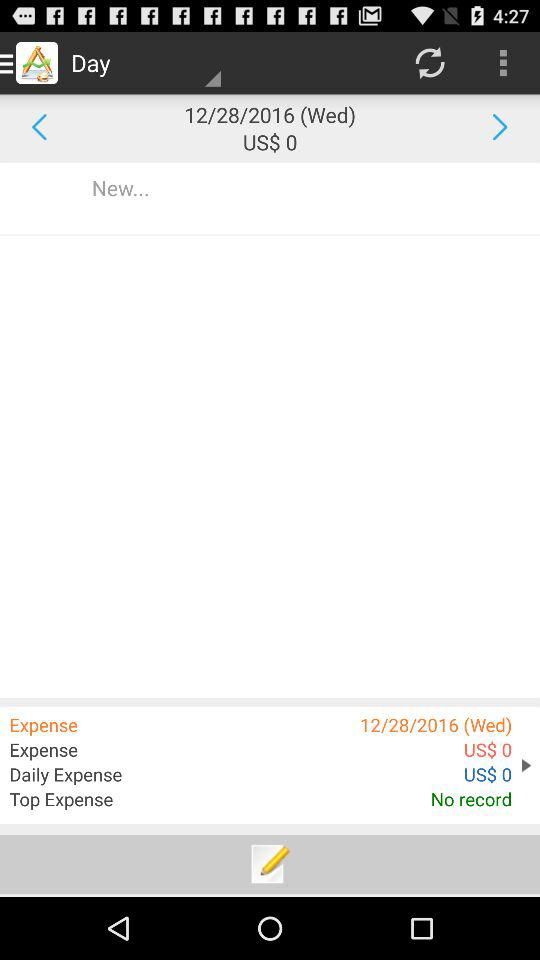How many days are there in the date range?
Answer the question using a single word or phrase. 1 